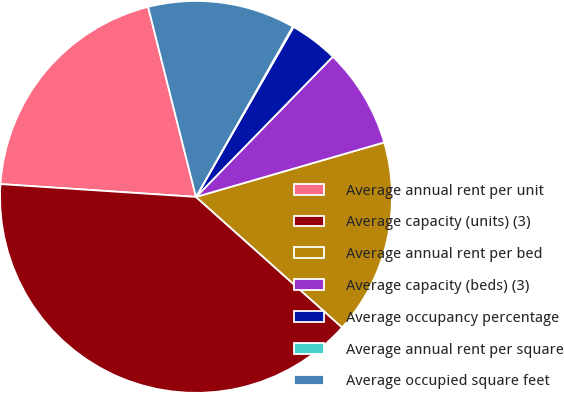<chart> <loc_0><loc_0><loc_500><loc_500><pie_chart><fcel>Average annual rent per unit<fcel>Average capacity (units) (3)<fcel>Average annual rent per bed<fcel>Average capacity (beds) (3)<fcel>Average occupancy percentage<fcel>Average annual rent per square<fcel>Average occupied square feet<nl><fcel>20.03%<fcel>39.44%<fcel>16.09%<fcel>8.21%<fcel>4.01%<fcel>0.07%<fcel>12.15%<nl></chart> 